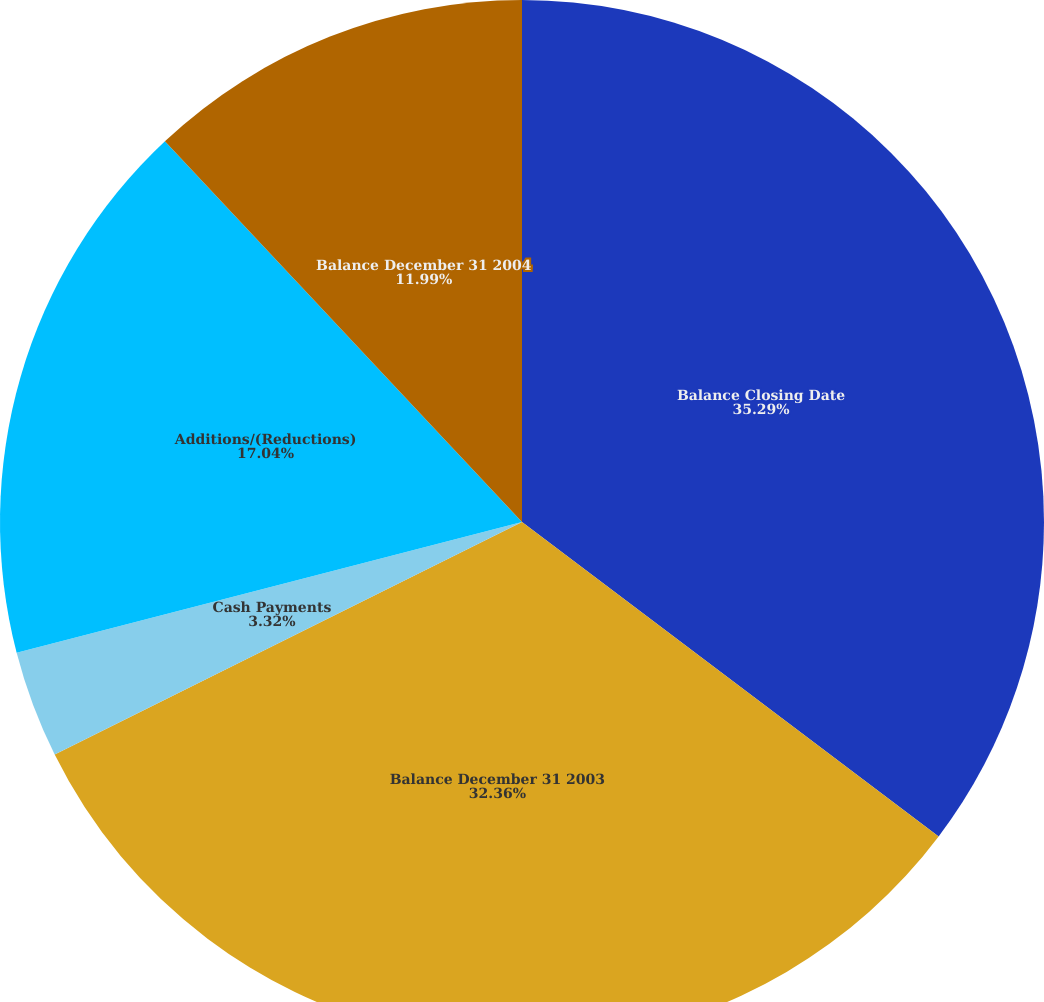Convert chart to OTSL. <chart><loc_0><loc_0><loc_500><loc_500><pie_chart><fcel>Balance Closing Date<fcel>Balance December 31 2003<fcel>Cash Payments<fcel>Additions/(Reductions)<fcel>Balance December 31 2004<nl><fcel>35.29%<fcel>32.36%<fcel>3.32%<fcel>17.04%<fcel>11.99%<nl></chart> 